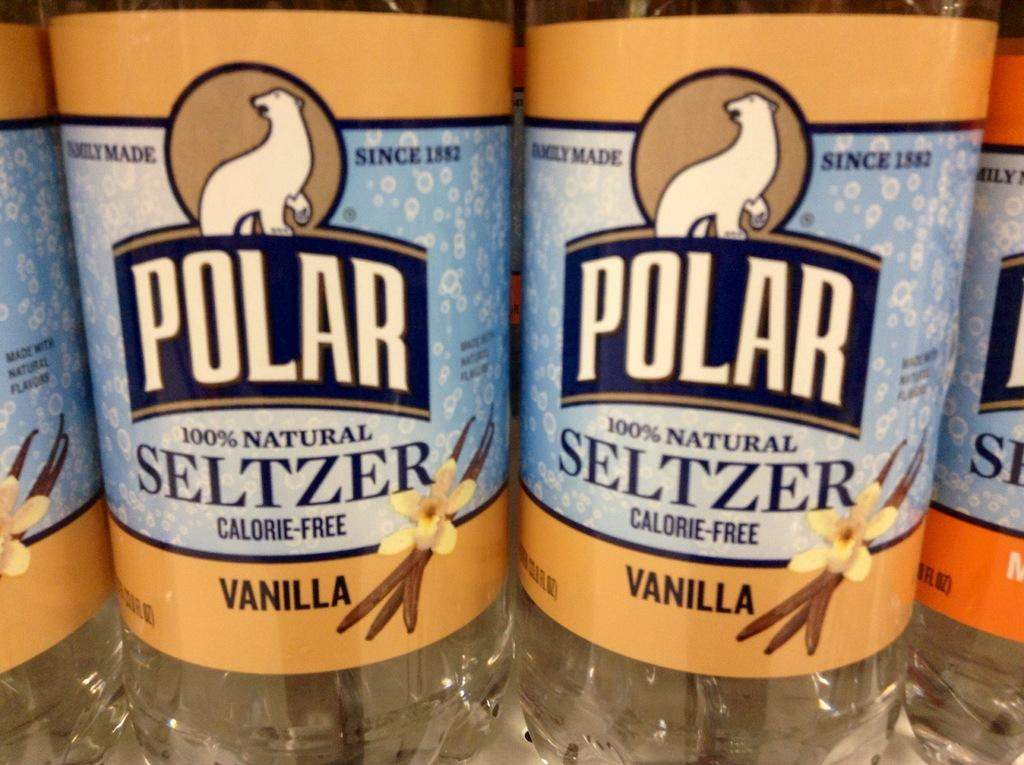<image>
Render a clear and concise summary of the photo. Bottles of Polar vanilla flavored seltzer are lined up next to each other. 